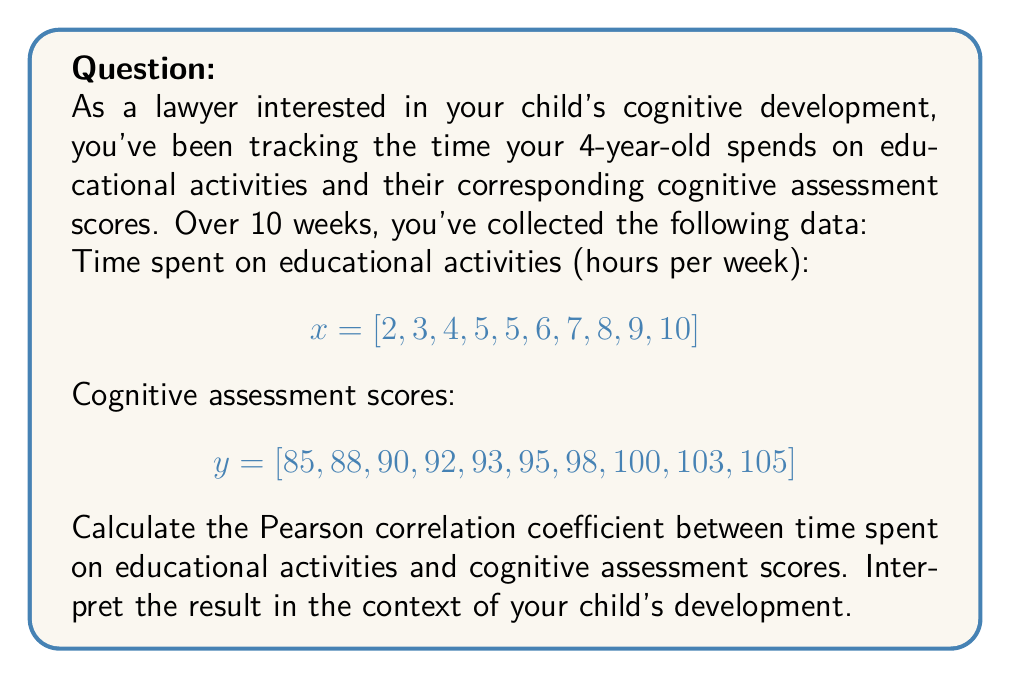Can you solve this math problem? To calculate the Pearson correlation coefficient, we'll use the formula:

$$ r = \frac{\sum_{i=1}^{n} (x_i - \bar{x})(y_i - \bar{y})}{\sqrt{\sum_{i=1}^{n} (x_i - \bar{x})^2} \sqrt{\sum_{i=1}^{n} (y_i - \bar{y})^2}} $$

Where:
$r$ is the Pearson correlation coefficient
$x_i$ and $y_i$ are individual sample points
$\bar{x}$ and $\bar{y}$ are the sample means

Step 1: Calculate the means
$\bar{x} = \frac{2 + 3 + 4 + 5 + 5 + 6 + 7 + 8 + 9 + 10}{10} = 5.9$
$\bar{y} = \frac{85 + 88 + 90 + 92 + 93 + 95 + 98 + 100 + 103 + 105}{10} = 94.9$

Step 2: Calculate $(x_i - \bar{x})$, $(y_i - \bar{y})$, $(x_i - \bar{x})^2$, $(y_i - \bar{y})^2$, and $(x_i - \bar{x})(y_i - \bar{y})$ for each pair of values.

Step 3: Sum up the calculated values:
$\sum (x_i - \bar{x})(y_i - \bar{y}) = 161.1$
$\sum (x_i - \bar{x})^2 = 70.9$
$\sum (y_i - \bar{y})^2 = 370.9$

Step 4: Apply the formula:

$$ r = \frac{161.1}{\sqrt{70.9} \sqrt{370.9}} = \frac{161.1}{\sqrt{26296.81}} = \frac{161.1}{162.16} = 0.9935 $$

Interpretation: The Pearson correlation coefficient of 0.9935 indicates a very strong positive correlation between time spent on educational activities and cognitive assessment scores. This suggests that as your child spends more time on educational activities, their cognitive assessment scores tend to increase proportionally.

However, it's important to note that correlation does not imply causation. While there's a strong relationship between these variables, other factors may also contribute to cognitive development. Additionally, this is based on a small sample size of 10 weeks, so long-term trends may vary.
Answer: The Pearson correlation coefficient is 0.9935, indicating a very strong positive correlation between time spent on educational activities and cognitive assessment scores. 